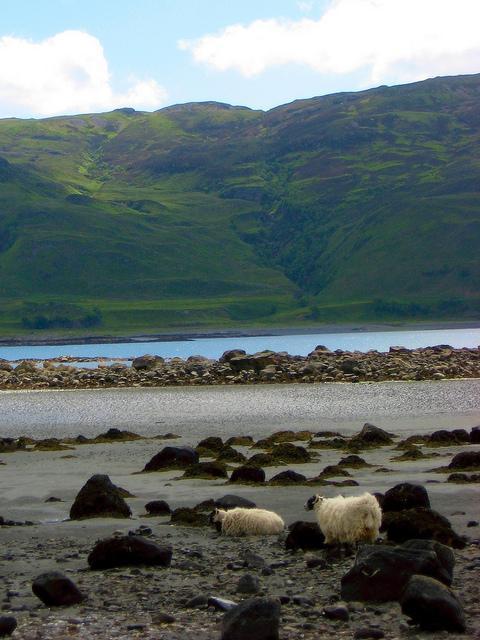How many animals are in the image?
Give a very brief answer. 2. How many people are on the stairs in the picture?
Give a very brief answer. 0. 